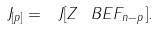Convert formula to latex. <formula><loc_0><loc_0><loc_500><loc_500>\ J _ { [ p ] } = \ J [ Z ^ { \ } B E F _ { n - p } ] .</formula> 